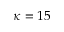Convert formula to latex. <formula><loc_0><loc_0><loc_500><loc_500>\kappa = 1 5</formula> 